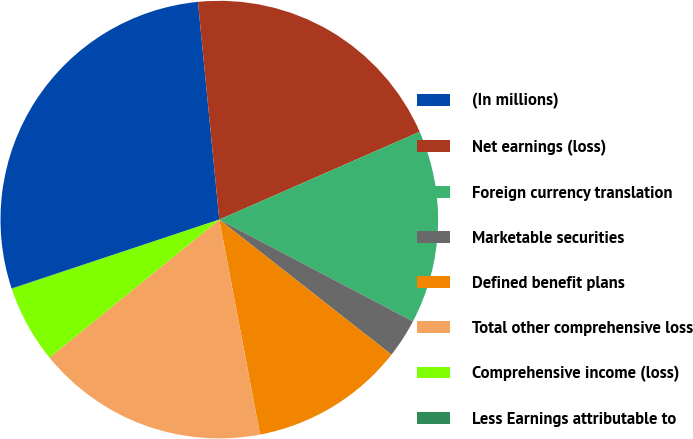Convert chart. <chart><loc_0><loc_0><loc_500><loc_500><pie_chart><fcel>(In millions)<fcel>Net earnings (loss)<fcel>Foreign currency translation<fcel>Marketable securities<fcel>Defined benefit plans<fcel>Total other comprehensive loss<fcel>Comprehensive income (loss)<fcel>Less Earnings attributable to<nl><fcel>28.54%<fcel>19.98%<fcel>14.28%<fcel>2.88%<fcel>11.43%<fcel>17.13%<fcel>5.73%<fcel>0.03%<nl></chart> 